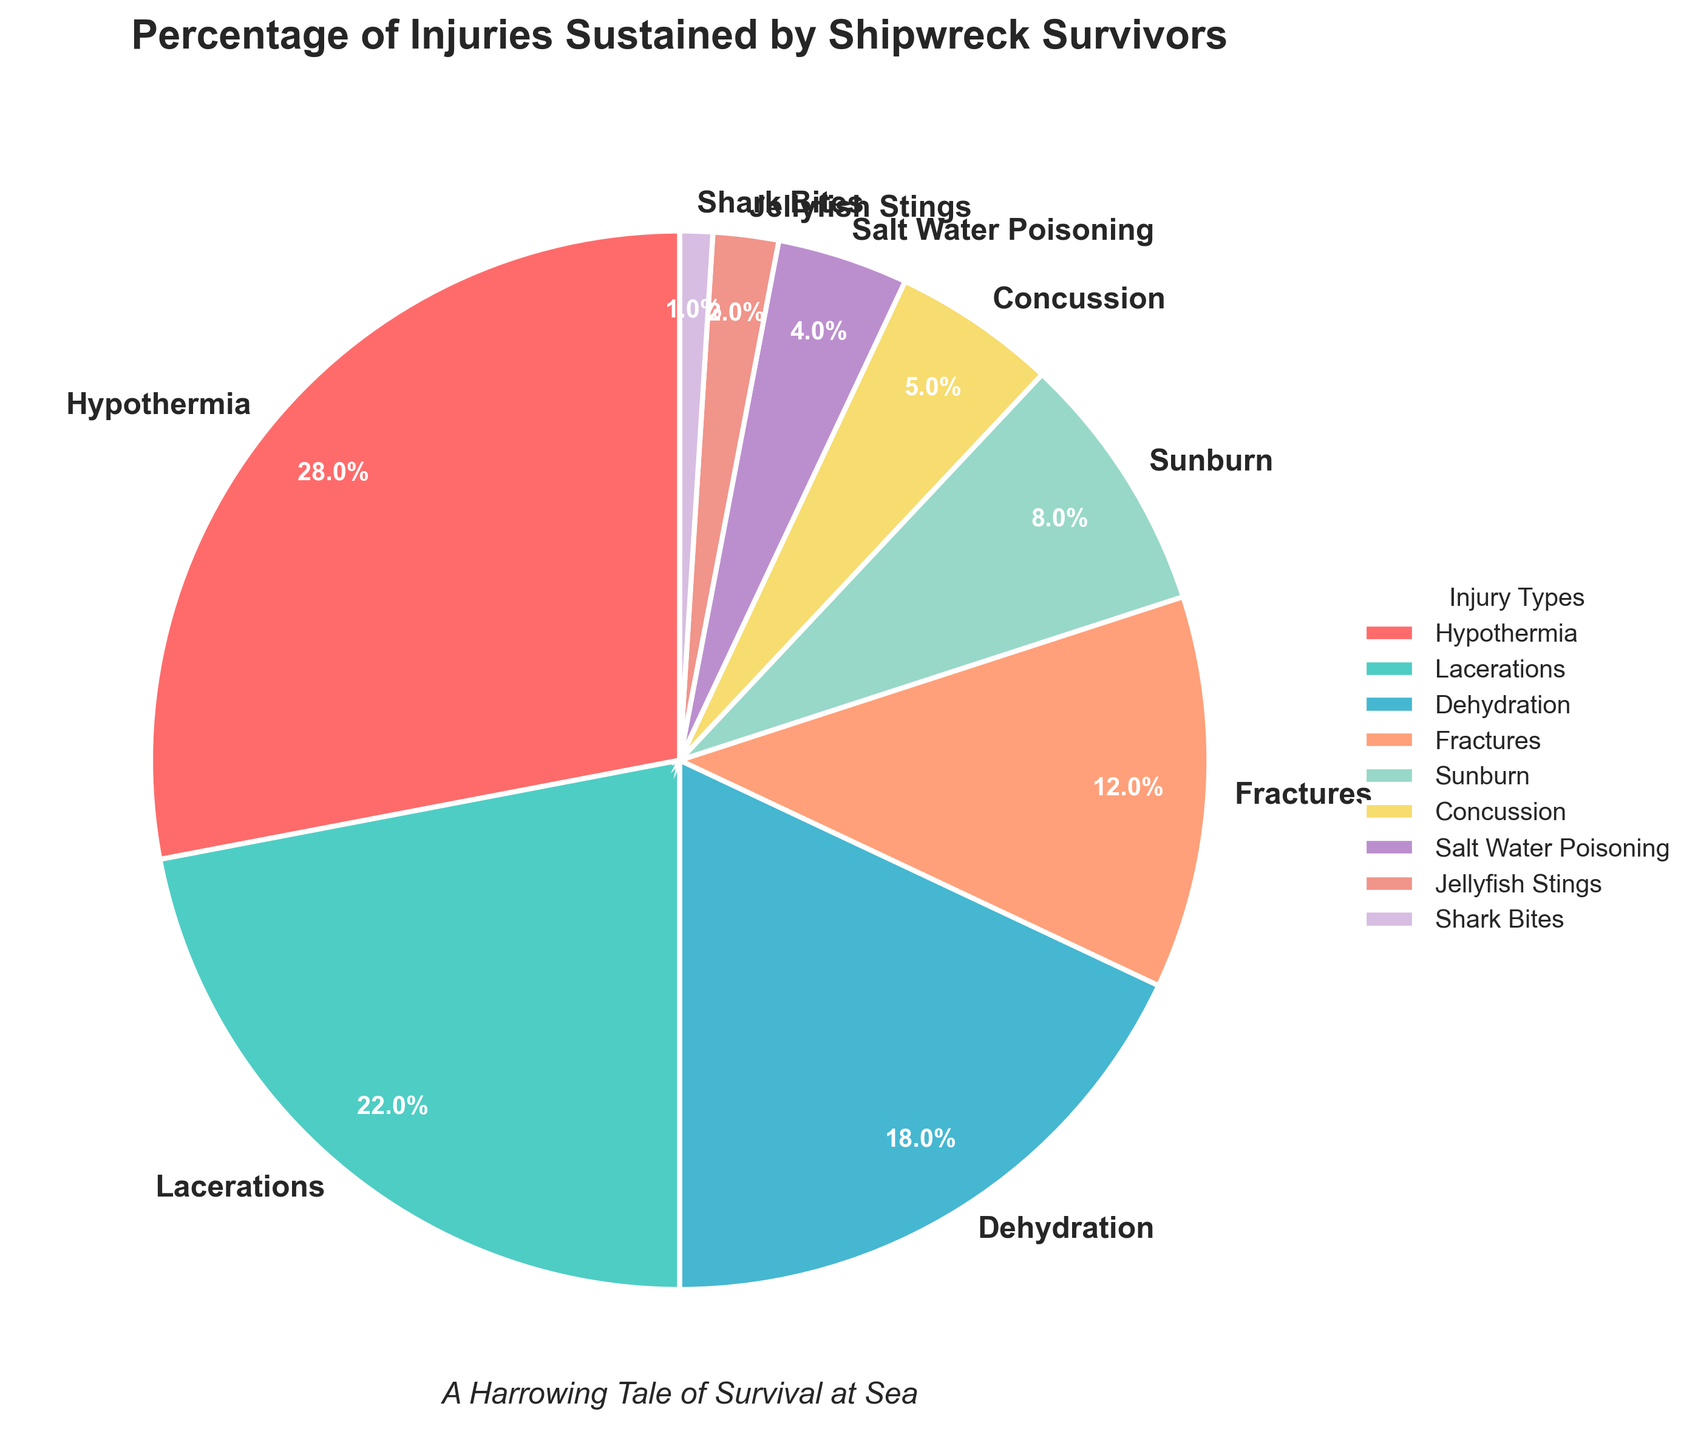Which injury type accounts for the largest percentage of injuries sustained by survivors? The largest percentage is indicated by the biggest wedge in the pie chart. The label for the largest wedge reads "Hypothermia – 28%".
Answer: Hypothermia What is the combined percentage of survivors suffering from lacerations and fractures? Summing up the percentages for lacerations (22%) and fractures (12%) gives us 22 + 12 = 34%.
Answer: 34% Is the percentage of dehydration-related injuries greater than the percentage of fractures? Comparing the two wedges, dehydration has a percentage of 18%, while fractures have a percentage of 12%. Since 18% is greater than 12%, the answer is yes.
Answer: Yes What is the difference in percentage between sunburn and dehydration injuries? The percentage for dehydration is 18%, and for sunburn, it is 8%. Subtracting these gives us 18% - 8% = 10%.
Answer: 10% Which two injury types together constitute close to 50% of all injuries? Looking at the pie chart, Hypothermia (28%) and Lacerations (22%) together make up 28% + 22% = 50%.
Answer: Hypothermia and Lacerations What is the least common type of injury sustained by survivors? The smallest wedge in the pie chart represents the least common injury, which is labeled as "Shark Bites – 1%".
Answer: Shark Bites How many injury types have a percentage less than 10%? The injury types with percentages less than 10% are sunburn (8%), concussion (5%), salt water poisoning (4%), jellyfish stings (2%), and shark bites (1%). Counting these gives us 5 injury types.
Answer: 5 Which color corresponds to the lacerations injury, and what percentage does it represent? Lacerations are represented by the second largest wedge, which is in green, and labeled as 22%.
Answer: Green, 22% If you combine the percentages of injuries represented by yellow and purple colors, what is the total? The yellow wedge represents Salt Water Poisoning (4%), and the purple wedge represents Concussion (5%). Adding these gives us 4% + 5% = 9%.
Answer: 9% If you were a survivor, which injury would you be most and least likely to sustain based on these percentages? The most likely injury to sustain is Hypothermia, which has the highest percentage at 28%. The least likely is Shark Bites, with the lowest percentage at 1%.
Answer: Hypothermia (most likely), Shark Bites (least likely) 